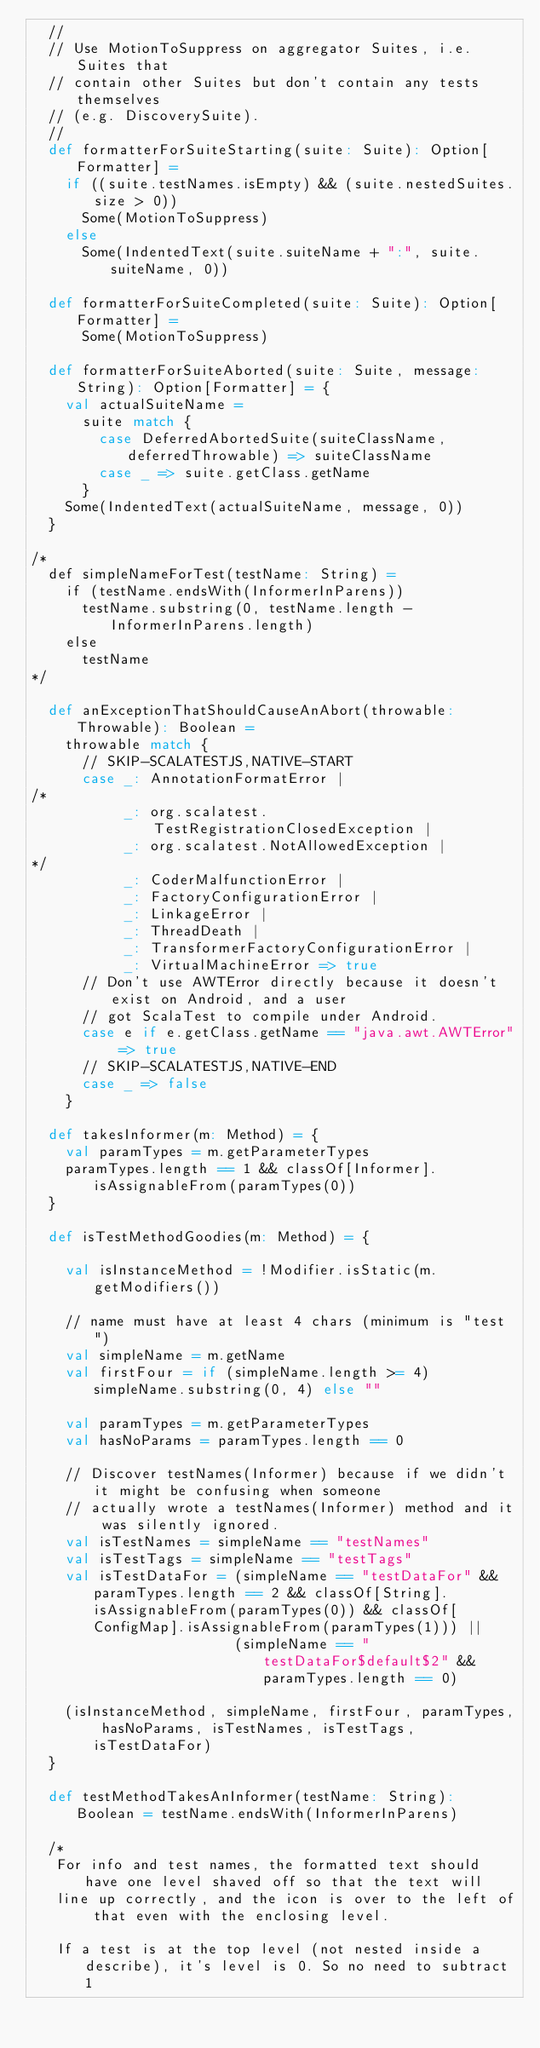<code> <loc_0><loc_0><loc_500><loc_500><_Scala_>  //
  // Use MotionToSuppress on aggregator Suites, i.e. Suites that
  // contain other Suites but don't contain any tests themselves
  // (e.g. DiscoverySuite).
  //
  def formatterForSuiteStarting(suite: Suite): Option[Formatter] =
    if ((suite.testNames.isEmpty) && (suite.nestedSuites.size > 0))
      Some(MotionToSuppress)
    else
      Some(IndentedText(suite.suiteName + ":", suite.suiteName, 0))

  def formatterForSuiteCompleted(suite: Suite): Option[Formatter] =
      Some(MotionToSuppress)

  def formatterForSuiteAborted(suite: Suite, message: String): Option[Formatter] = {
    val actualSuiteName =
      suite match {
        case DeferredAbortedSuite(suiteClassName, deferredThrowable) => suiteClassName
        case _ => suite.getClass.getName
      }
    Some(IndentedText(actualSuiteName, message, 0))
  }

/*
  def simpleNameForTest(testName: String) =
    if (testName.endsWith(InformerInParens))
      testName.substring(0, testName.length - InformerInParens.length)
    else
      testName
*/

  def anExceptionThatShouldCauseAnAbort(throwable: Throwable): Boolean =
    throwable match {
      // SKIP-SCALATESTJS,NATIVE-START
      case _: AnnotationFormatError | 
/*
           _: org.scalatest.TestRegistrationClosedException |
           _: org.scalatest.NotAllowedException |
*/
           _: CoderMalfunctionError |
           _: FactoryConfigurationError | 
           _: LinkageError | 
           _: ThreadDeath | 
           _: TransformerFactoryConfigurationError | 
           _: VirtualMachineError => true
      // Don't use AWTError directly because it doesn't exist on Android, and a user
      // got ScalaTest to compile under Android.
      case e if e.getClass.getName == "java.awt.AWTError" => true
      // SKIP-SCALATESTJS,NATIVE-END
      case _ => false
    }

  def takesInformer(m: Method) = {
    val paramTypes = m.getParameterTypes
    paramTypes.length == 1 && classOf[Informer].isAssignableFrom(paramTypes(0))
  }

  def isTestMethodGoodies(m: Method) = {

    val isInstanceMethod = !Modifier.isStatic(m.getModifiers())

    // name must have at least 4 chars (minimum is "test")
    val simpleName = m.getName
    val firstFour = if (simpleName.length >= 4) simpleName.substring(0, 4) else "" 

    val paramTypes = m.getParameterTypes
    val hasNoParams = paramTypes.length == 0

    // Discover testNames(Informer) because if we didn't it might be confusing when someone
    // actually wrote a testNames(Informer) method and it was silently ignored.
    val isTestNames = simpleName == "testNames"
    val isTestTags = simpleName == "testTags"
    val isTestDataFor = (simpleName == "testDataFor" && paramTypes.length == 2 && classOf[String].isAssignableFrom(paramTypes(0)) && classOf[ConfigMap].isAssignableFrom(paramTypes(1))) || 
                        (simpleName == "testDataFor$default$2" && paramTypes.length == 0)

    (isInstanceMethod, simpleName, firstFour, paramTypes, hasNoParams, isTestNames, isTestTags, isTestDataFor)
  }

  def testMethodTakesAnInformer(testName: String): Boolean = testName.endsWith(InformerInParens)

  /*
   For info and test names, the formatted text should have one level shaved off so that the text will
   line up correctly, and the icon is over to the left of that even with the enclosing level.

   If a test is at the top level (not nested inside a describe), it's level is 0. So no need to subtract 1</code> 